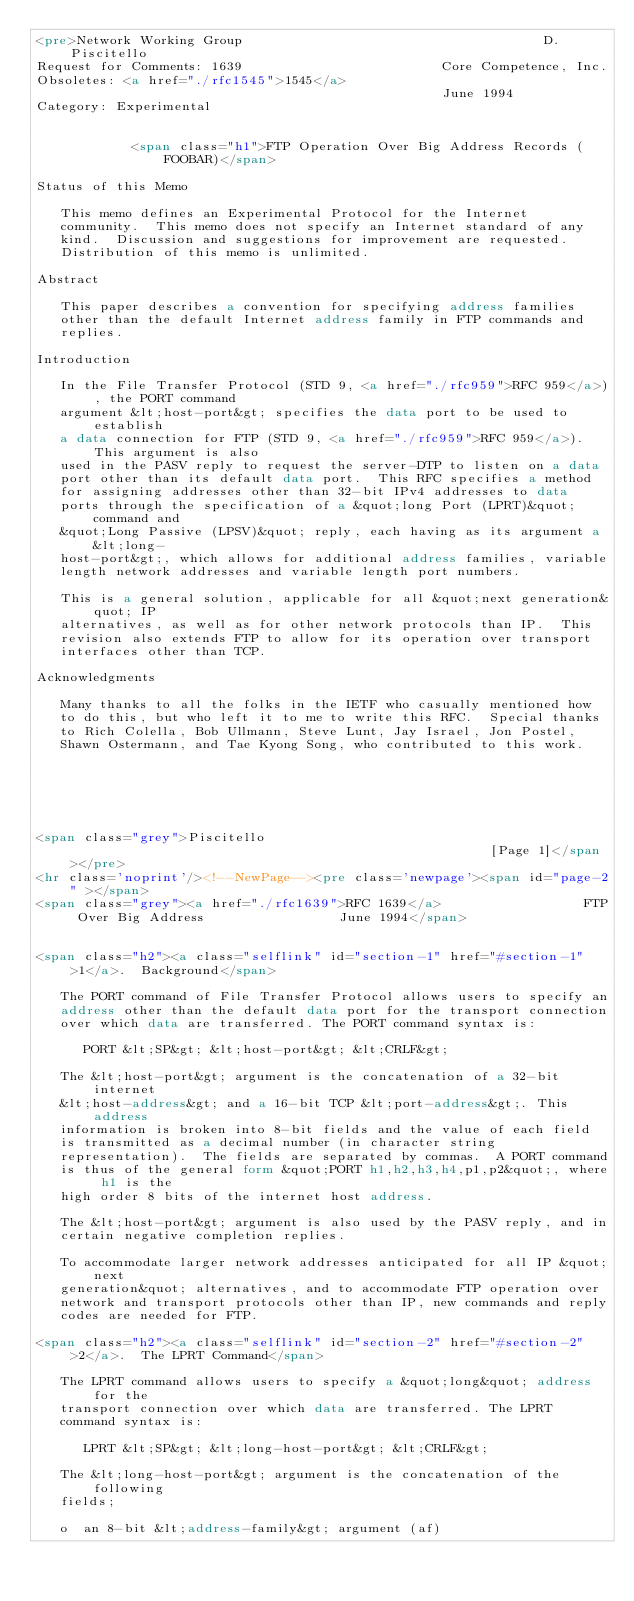Convert code to text. <code><loc_0><loc_0><loc_500><loc_500><_HTML_><pre>Network Working Group                                      D. Piscitello
Request for Comments: 1639                         Core Competence, Inc.
Obsoletes: <a href="./rfc1545">1545</a>                                                June 1994
Category: Experimental


            <span class="h1">FTP Operation Over Big Address Records (FOOBAR)</span>

Status of this Memo

   This memo defines an Experimental Protocol for the Internet
   community.  This memo does not specify an Internet standard of any
   kind.  Discussion and suggestions for improvement are requested.
   Distribution of this memo is unlimited.

Abstract

   This paper describes a convention for specifying address families
   other than the default Internet address family in FTP commands and
   replies.

Introduction

   In the File Transfer Protocol (STD 9, <a href="./rfc959">RFC 959</a>), the PORT command
   argument &lt;host-port&gt; specifies the data port to be used to establish
   a data connection for FTP (STD 9, <a href="./rfc959">RFC 959</a>).  This argument is also
   used in the PASV reply to request the server-DTP to listen on a data
   port other than its default data port.  This RFC specifies a method
   for assigning addresses other than 32-bit IPv4 addresses to data
   ports through the specification of a &quot;long Port (LPRT)&quot; command and
   &quot;Long Passive (LPSV)&quot; reply, each having as its argument a &lt;long-
   host-port&gt;, which allows for additional address families, variable
   length network addresses and variable length port numbers.

   This is a general solution, applicable for all &quot;next generation&quot; IP
   alternatives, as well as for other network protocols than IP.  This
   revision also extends FTP to allow for its operation over transport
   interfaces other than TCP.

Acknowledgments

   Many thanks to all the folks in the IETF who casually mentioned how
   to do this, but who left it to me to write this RFC.  Special thanks
   to Rich Colella, Bob Ullmann, Steve Lunt, Jay Israel, Jon Postel,
   Shawn Ostermann, and Tae Kyong Song, who contributed to this work.






<span class="grey">Piscitello                                                      [Page 1]</span></pre>
<hr class='noprint'/><!--NewPage--><pre class='newpage'><span id="page-2" ></span>
<span class="grey"><a href="./rfc1639">RFC 1639</a>                  FTP Over Big Address                 June 1994</span>


<span class="h2"><a class="selflink" id="section-1" href="#section-1">1</a>.  Background</span>

   The PORT command of File Transfer Protocol allows users to specify an
   address other than the default data port for the transport connection
   over which data are transferred. The PORT command syntax is:

      PORT &lt;SP&gt; &lt;host-port&gt; &lt;CRLF&gt;

   The &lt;host-port&gt; argument is the concatenation of a 32-bit internet
   &lt;host-address&gt; and a 16-bit TCP &lt;port-address&gt;. This address
   information is broken into 8-bit fields and the value of each field
   is transmitted as a decimal number (in character string
   representation).  The fields are separated by commas.  A PORT command
   is thus of the general form &quot;PORT h1,h2,h3,h4,p1,p2&quot;, where h1 is the
   high order 8 bits of the internet host address.

   The &lt;host-port&gt; argument is also used by the PASV reply, and in
   certain negative completion replies.

   To accommodate larger network addresses anticipated for all IP &quot;next
   generation&quot; alternatives, and to accommodate FTP operation over
   network and transport protocols other than IP, new commands and reply
   codes are needed for FTP.

<span class="h2"><a class="selflink" id="section-2" href="#section-2">2</a>.  The LPRT Command</span>

   The LPRT command allows users to specify a &quot;long&quot; address for the
   transport connection over which data are transferred. The LPRT
   command syntax is:

      LPRT &lt;SP&gt; &lt;long-host-port&gt; &lt;CRLF&gt;

   The &lt;long-host-port&gt; argument is the concatenation of the following
   fields;

   o  an 8-bit &lt;address-family&gt; argument (af)
</code> 